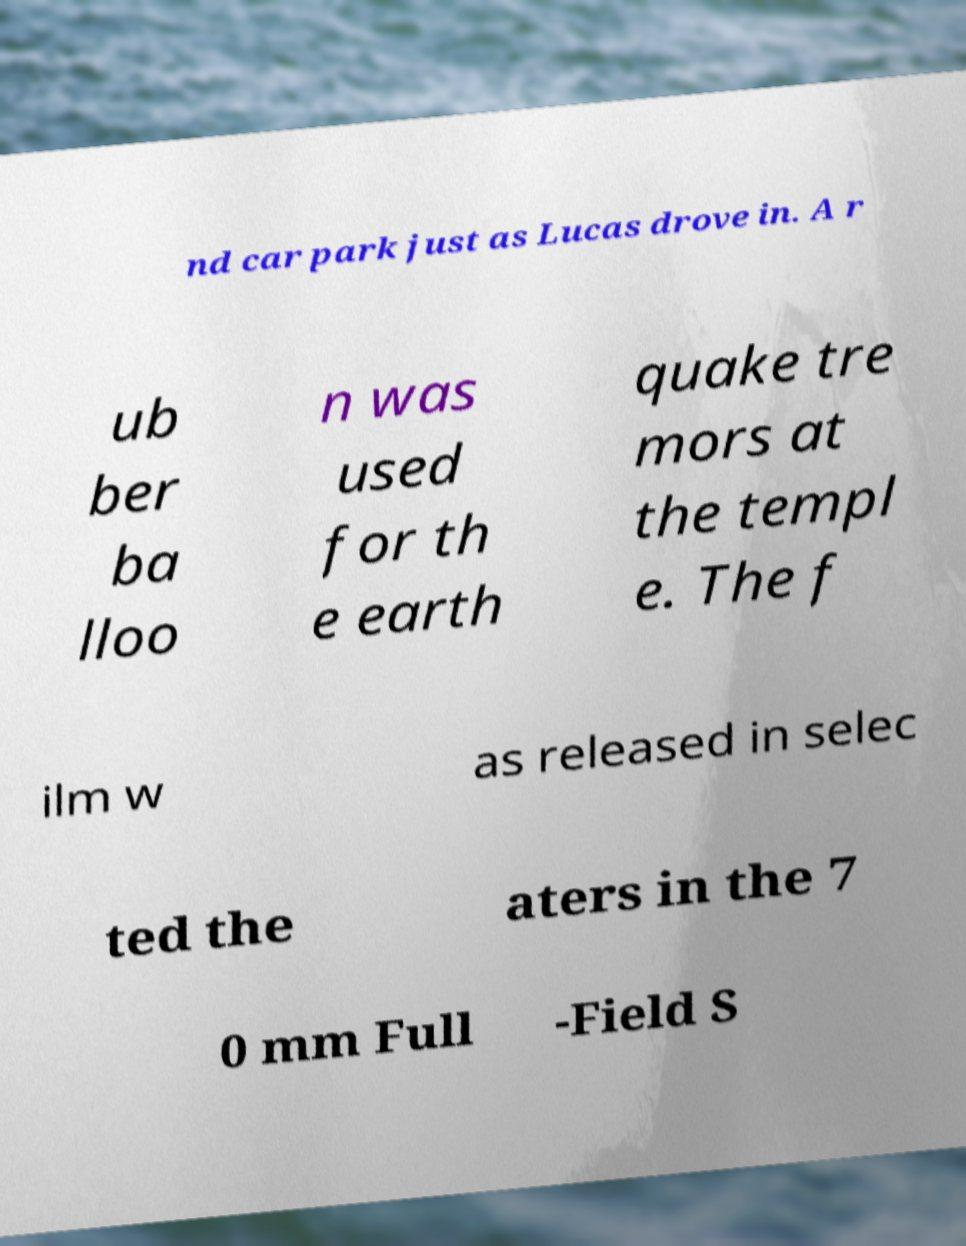I need the written content from this picture converted into text. Can you do that? nd car park just as Lucas drove in. A r ub ber ba lloo n was used for th e earth quake tre mors at the templ e. The f ilm w as released in selec ted the aters in the 7 0 mm Full -Field S 